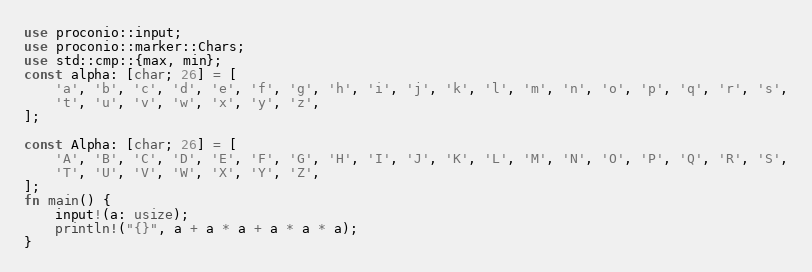<code> <loc_0><loc_0><loc_500><loc_500><_Rust_>use proconio::input;
use proconio::marker::Chars;
use std::cmp::{max, min};
const alpha: [char; 26] = [
    'a', 'b', 'c', 'd', 'e', 'f', 'g', 'h', 'i', 'j', 'k', 'l', 'm', 'n', 'o', 'p', 'q', 'r', 's',
    't', 'u', 'v', 'w', 'x', 'y', 'z',
];

const Alpha: [char; 26] = [
    'A', 'B', 'C', 'D', 'E', 'F', 'G', 'H', 'I', 'J', 'K', 'L', 'M', 'N', 'O', 'P', 'Q', 'R', 'S',
    'T', 'U', 'V', 'W', 'X', 'Y', 'Z',
];
fn main() {
    input!(a: usize);
    println!("{}", a + a * a + a * a * a);
}
</code> 